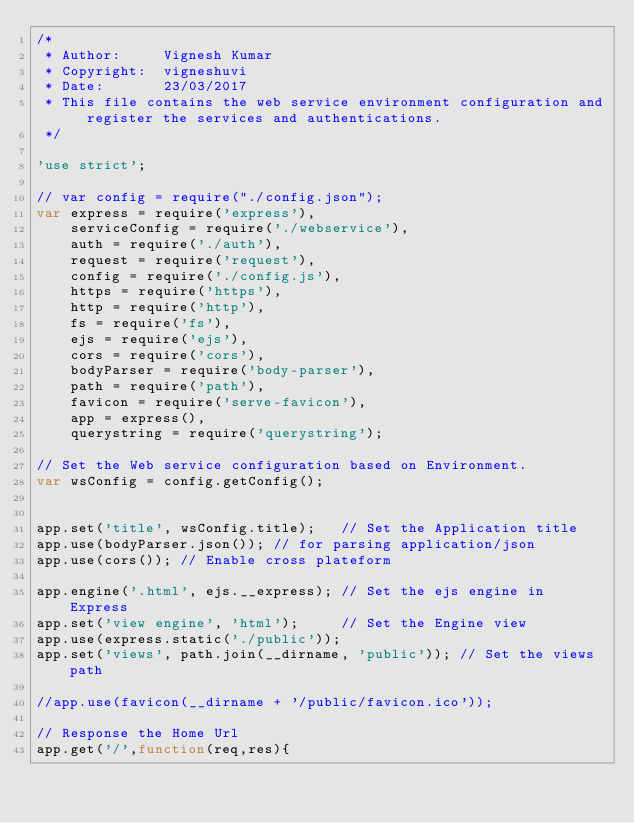Convert code to text. <code><loc_0><loc_0><loc_500><loc_500><_JavaScript_>/*
 * Author:     Vignesh Kumar
 * Copyright:  vigneshuvi
 * Date:	   23/03/2017
 * This file contains the web service environment configuration and register the services and authentications.
 */

'use strict';

// var config = require("./config.json"); 
var express = require('express'),
	serviceConfig = require('./webservice'),
	auth = require('./auth'),
	request = require('request'),
	config = require('./config.js'),
	https = require('https'),
	http = require('http'),
	fs = require('fs'),
	ejs = require('ejs'),
	cors = require('cors'),
	bodyParser = require('body-parser'),
	path = require('path'),
	favicon = require('serve-favicon'),
	app = express(),
	querystring = require('querystring');

// Set the Web service configuration based on Environment.
var wsConfig = config.getConfig();


app.set('title', wsConfig.title);	// Set the Application title
app.use(bodyParser.json());	// for parsing application/json
app.use(cors()); // Enable cross plateform

app.engine('.html', ejs.__express); // Set the ejs engine in Express
app.set('view engine', 'html');		// Set the Engine view
app.use(express.static('./public'));
app.set('views', path.join(__dirname, 'public')); // Set the views path

//app.use(favicon(__dirname + '/public/favicon.ico'));

// Response the Home Url
app.get('/',function(req,res){</code> 